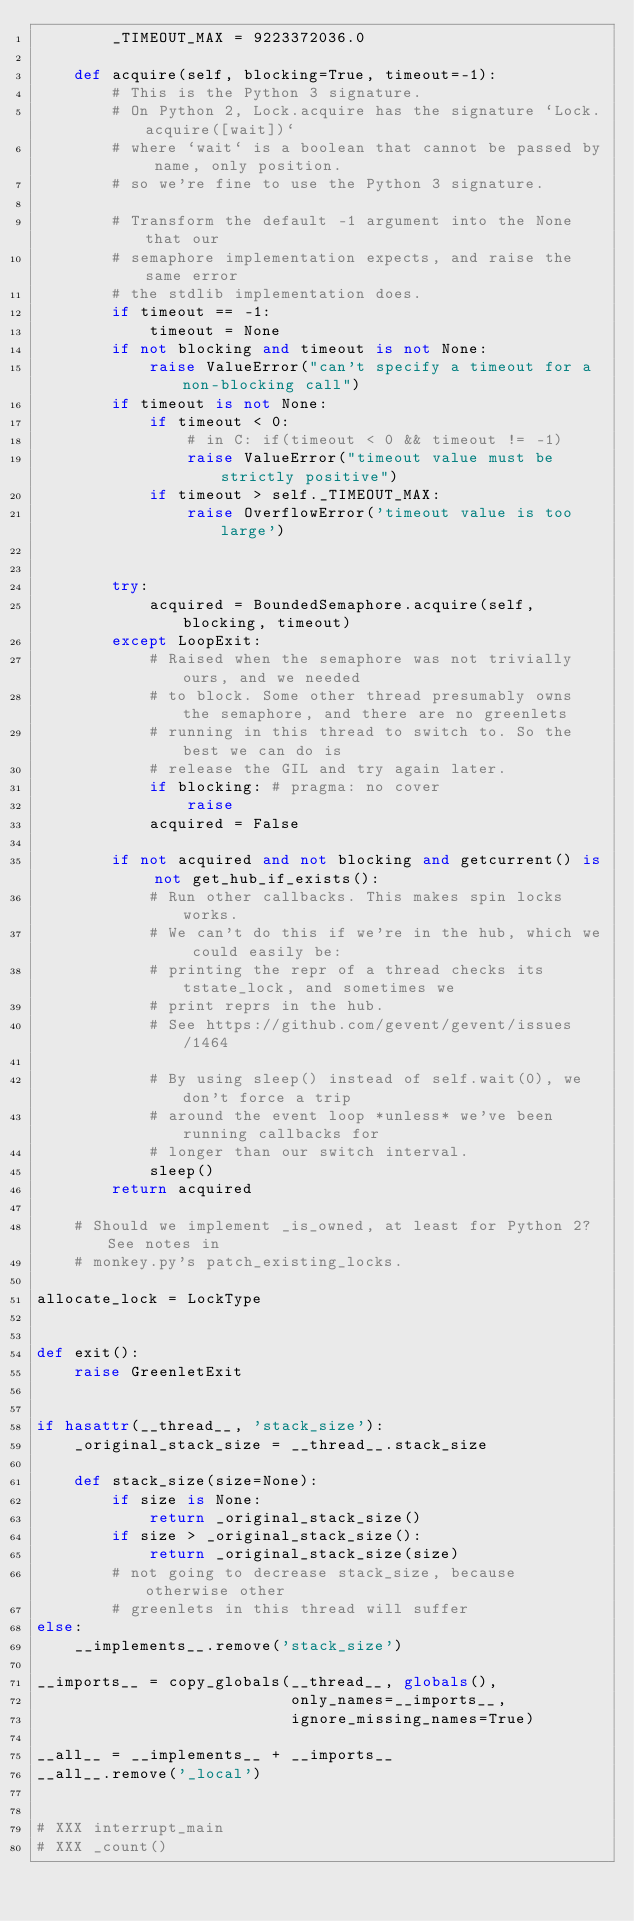Convert code to text. <code><loc_0><loc_0><loc_500><loc_500><_Python_>        _TIMEOUT_MAX = 9223372036.0

    def acquire(self, blocking=True, timeout=-1):
        # This is the Python 3 signature.
        # On Python 2, Lock.acquire has the signature `Lock.acquire([wait])`
        # where `wait` is a boolean that cannot be passed by name, only position.
        # so we're fine to use the Python 3 signature.

        # Transform the default -1 argument into the None that our
        # semaphore implementation expects, and raise the same error
        # the stdlib implementation does.
        if timeout == -1:
            timeout = None
        if not blocking and timeout is not None:
            raise ValueError("can't specify a timeout for a non-blocking call")
        if timeout is not None:
            if timeout < 0:
                # in C: if(timeout < 0 && timeout != -1)
                raise ValueError("timeout value must be strictly positive")
            if timeout > self._TIMEOUT_MAX:
                raise OverflowError('timeout value is too large')


        try:
            acquired = BoundedSemaphore.acquire(self, blocking, timeout)
        except LoopExit:
            # Raised when the semaphore was not trivially ours, and we needed
            # to block. Some other thread presumably owns the semaphore, and there are no greenlets
            # running in this thread to switch to. So the best we can do is
            # release the GIL and try again later.
            if blocking: # pragma: no cover
                raise
            acquired = False

        if not acquired and not blocking and getcurrent() is not get_hub_if_exists():
            # Run other callbacks. This makes spin locks works.
            # We can't do this if we're in the hub, which we could easily be:
            # printing the repr of a thread checks its tstate_lock, and sometimes we
            # print reprs in the hub.
            # See https://github.com/gevent/gevent/issues/1464

            # By using sleep() instead of self.wait(0), we don't force a trip
            # around the event loop *unless* we've been running callbacks for
            # longer than our switch interval.
            sleep()
        return acquired

    # Should we implement _is_owned, at least for Python 2? See notes in
    # monkey.py's patch_existing_locks.

allocate_lock = LockType


def exit():
    raise GreenletExit


if hasattr(__thread__, 'stack_size'):
    _original_stack_size = __thread__.stack_size

    def stack_size(size=None):
        if size is None:
            return _original_stack_size()
        if size > _original_stack_size():
            return _original_stack_size(size)
        # not going to decrease stack_size, because otherwise other
        # greenlets in this thread will suffer
else:
    __implements__.remove('stack_size')

__imports__ = copy_globals(__thread__, globals(),
                           only_names=__imports__,
                           ignore_missing_names=True)

__all__ = __implements__ + __imports__
__all__.remove('_local')


# XXX interrupt_main
# XXX _count()
</code> 